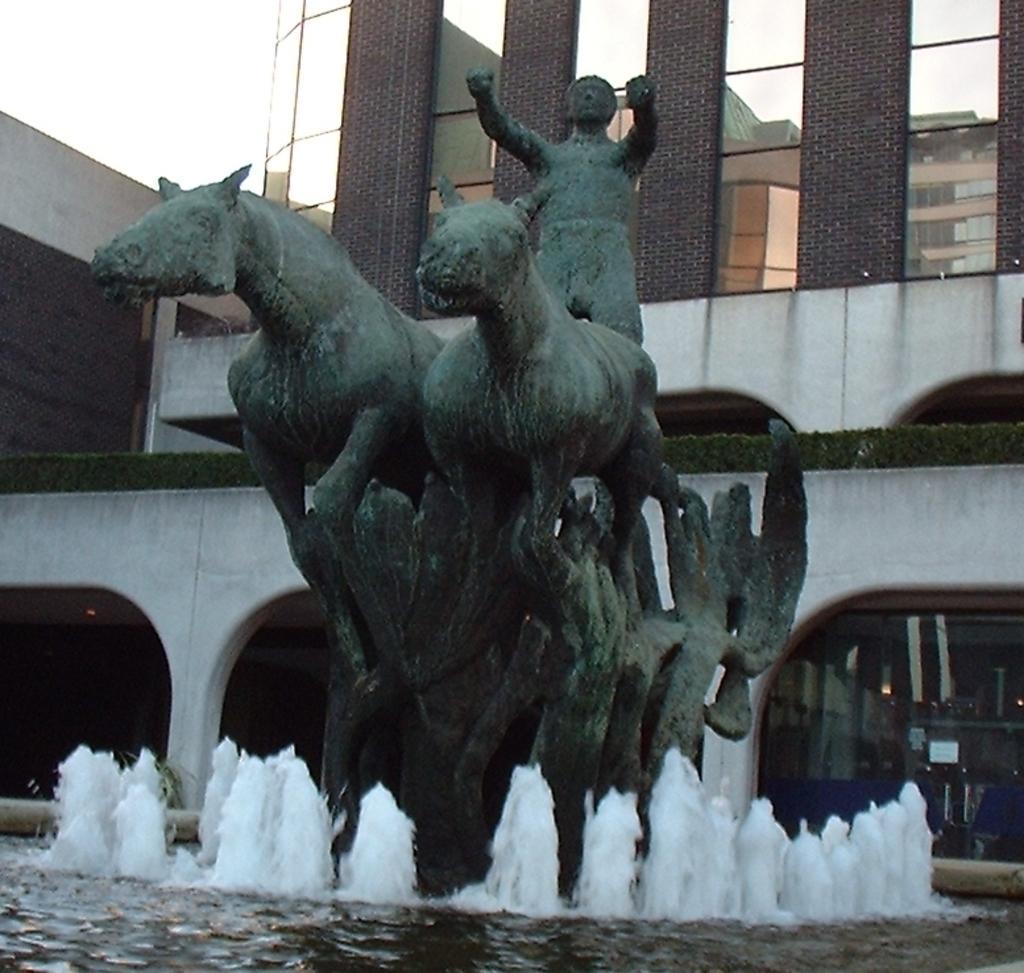Describe this image in one or two sentences. In the picture we can see a sculpture with two horses and a man on the cart standing and near it, we can see a fountain and in the background we can see a house building with pillars and a sky. 